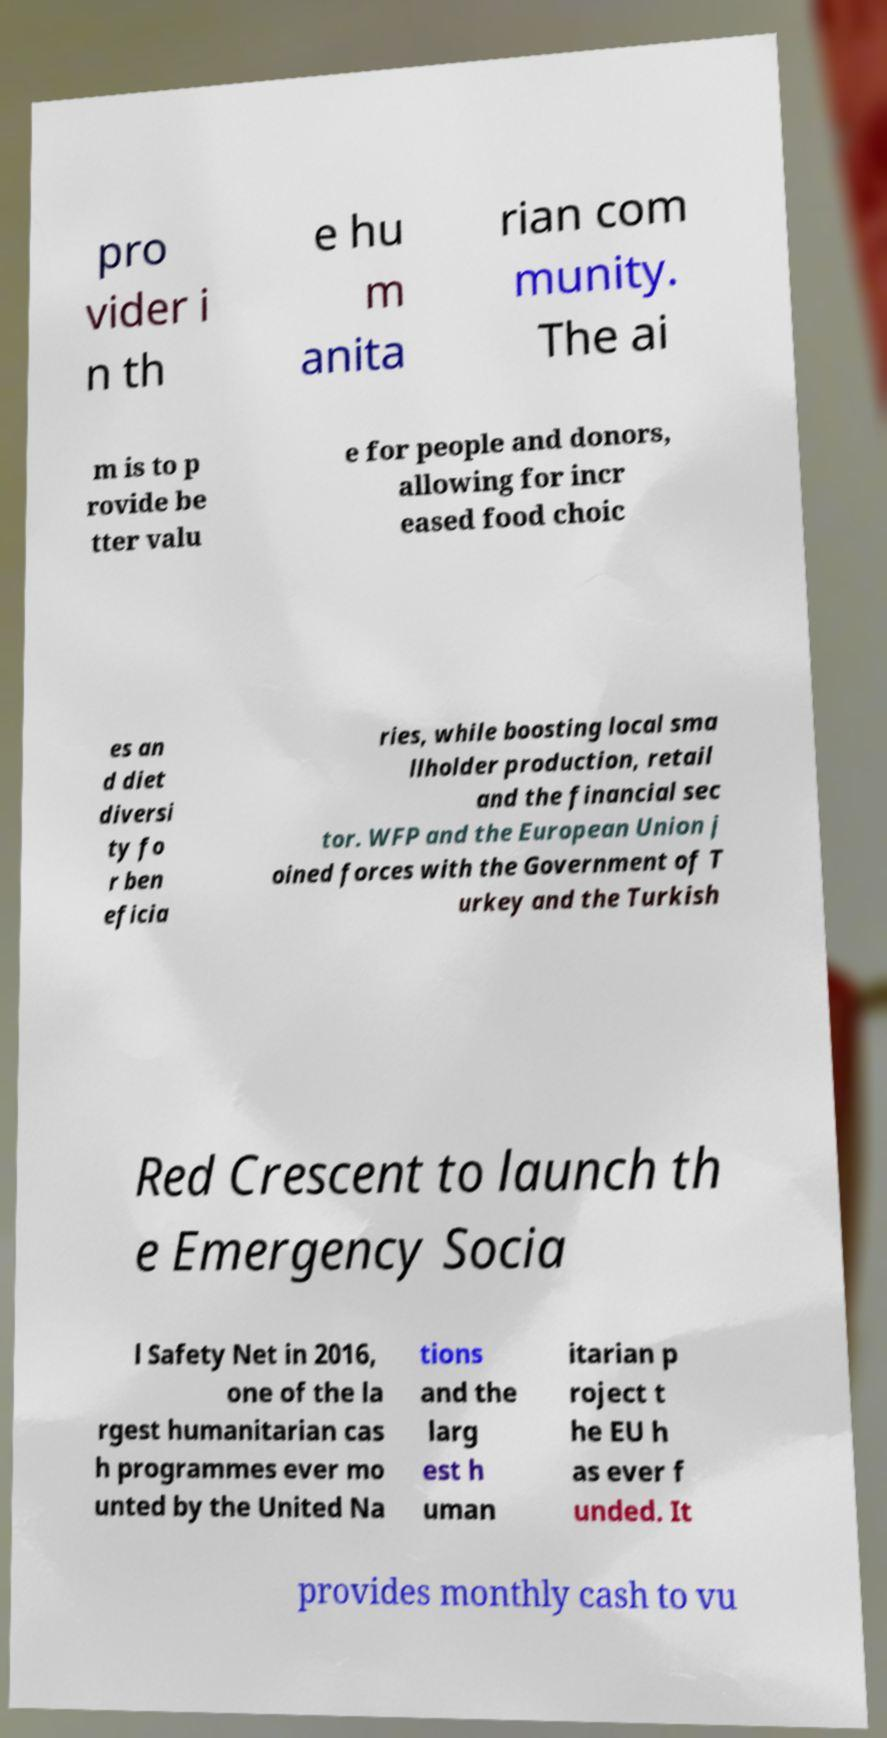Can you read and provide the text displayed in the image?This photo seems to have some interesting text. Can you extract and type it out for me? pro vider i n th e hu m anita rian com munity. The ai m is to p rovide be tter valu e for people and donors, allowing for incr eased food choic es an d diet diversi ty fo r ben eficia ries, while boosting local sma llholder production, retail and the financial sec tor. WFP and the European Union j oined forces with the Government of T urkey and the Turkish Red Crescent to launch th e Emergency Socia l Safety Net in 2016, one of the la rgest humanitarian cas h programmes ever mo unted by the United Na tions and the larg est h uman itarian p roject t he EU h as ever f unded. It provides monthly cash to vu 